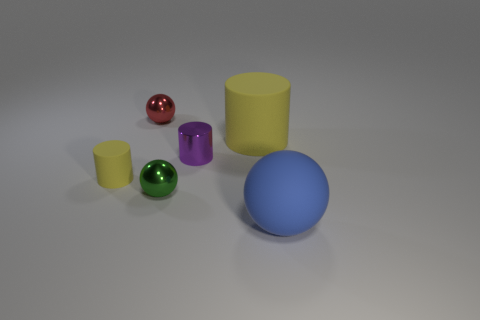What number of big things are either green things or shiny things?
Your answer should be compact. 0. Are there any large metallic spheres?
Give a very brief answer. No. Are there more small purple cylinders that are right of the small purple metal cylinder than metal cylinders that are in front of the small yellow thing?
Ensure brevity in your answer.  No. There is a small ball behind the tiny cylinder on the left side of the green metallic object; what color is it?
Provide a short and direct response. Red. Are there any large cylinders of the same color as the small rubber cylinder?
Make the answer very short. Yes. What is the size of the yellow thing that is behind the matte cylinder that is on the left side of the small shiny ball to the left of the tiny green metallic object?
Your response must be concise. Large. The large yellow object is what shape?
Provide a short and direct response. Cylinder. There is a rubber cylinder that is the same color as the tiny rubber thing; what size is it?
Offer a terse response. Large. There is a large rubber object that is behind the green sphere; how many green metallic things are in front of it?
Make the answer very short. 1. How many other objects are there of the same material as the tiny red object?
Your answer should be very brief. 2. 